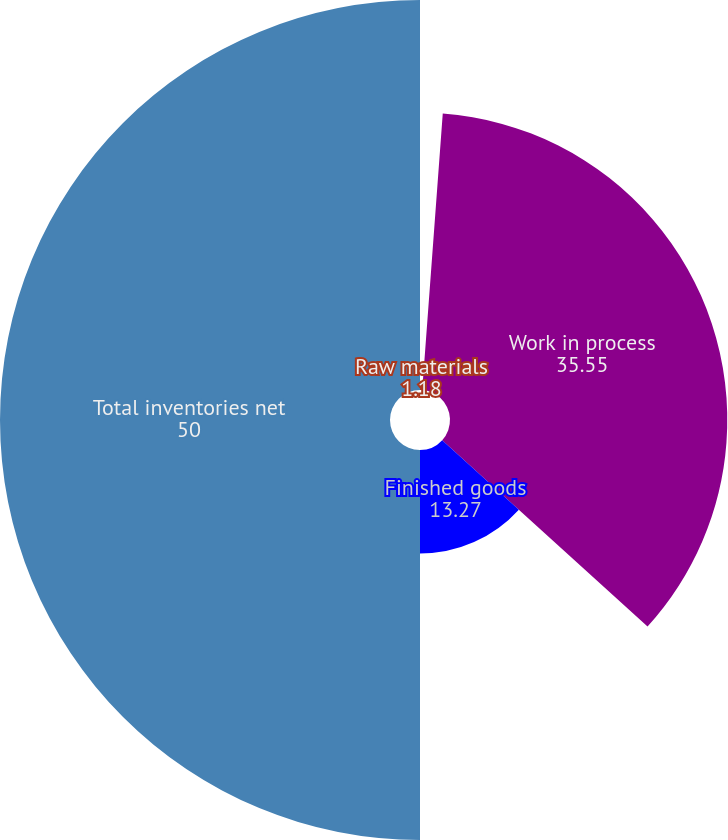<chart> <loc_0><loc_0><loc_500><loc_500><pie_chart><fcel>Raw materials<fcel>Work in process<fcel>Finished goods<fcel>Total inventories net<nl><fcel>1.18%<fcel>35.55%<fcel>13.27%<fcel>50.0%<nl></chart> 